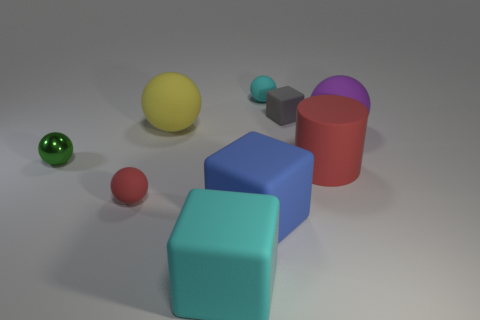How many objects are big cyan matte cylinders or matte objects that are in front of the purple matte thing?
Offer a terse response. 4. There is a cyan cube on the left side of the large blue object; what size is it?
Your answer should be very brief. Large. Are there fewer tiny gray matte objects to the right of the red matte cylinder than small rubber blocks that are left of the yellow rubber sphere?
Provide a succinct answer. No. What material is the big object that is both in front of the large cylinder and to the left of the large blue matte cube?
Your answer should be compact. Rubber. The cyan thing that is in front of the big sphere to the left of the cyan rubber ball is what shape?
Offer a very short reply. Cube. Do the metal sphere and the large matte cylinder have the same color?
Your answer should be compact. No. What number of cyan objects are small metal things or small things?
Your answer should be compact. 1. Are there any cyan matte blocks to the left of the yellow object?
Make the answer very short. No. What is the size of the purple sphere?
Provide a succinct answer. Large. There is a cyan object that is the same shape as the tiny gray matte thing; what size is it?
Give a very brief answer. Large. 